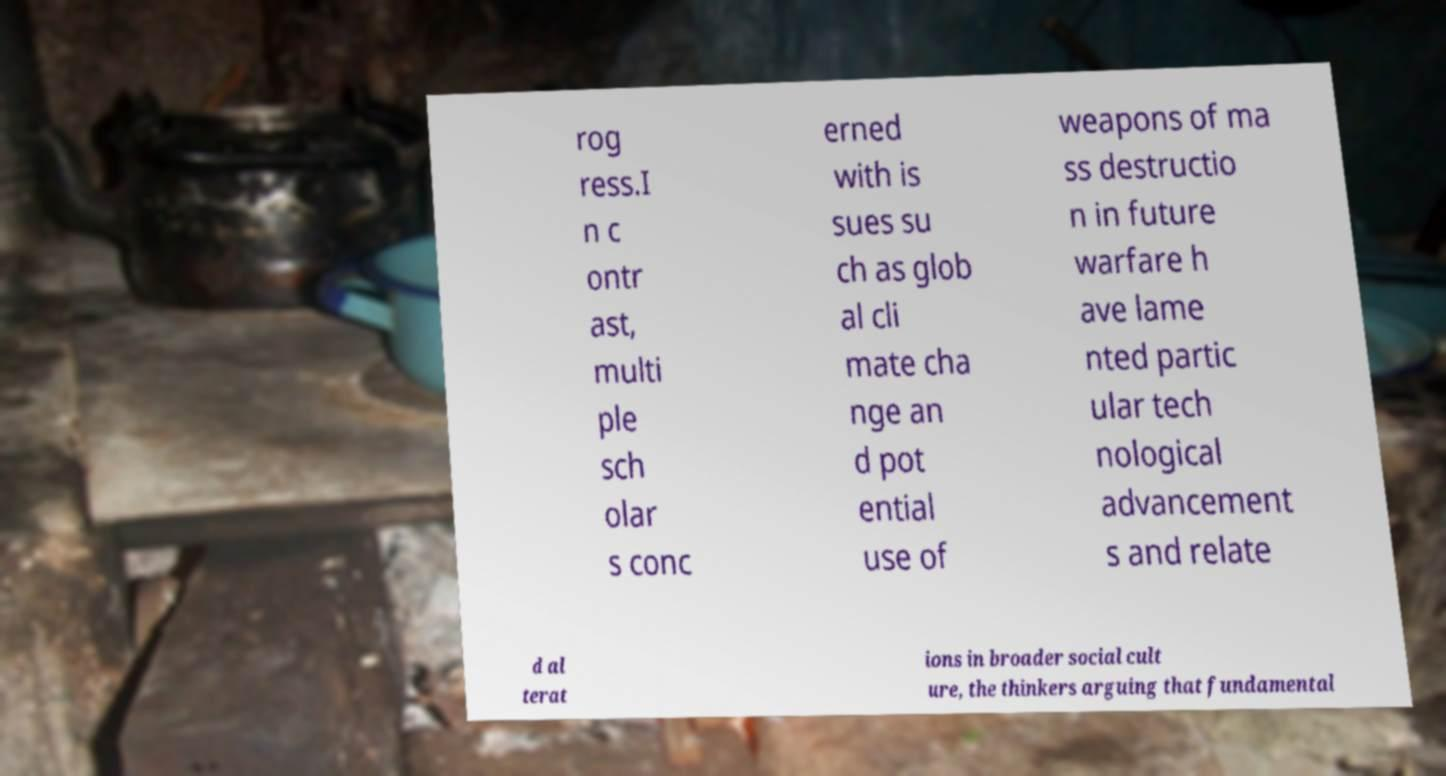What messages or text are displayed in this image? I need them in a readable, typed format. rog ress.I n c ontr ast, multi ple sch olar s conc erned with is sues su ch as glob al cli mate cha nge an d pot ential use of weapons of ma ss destructio n in future warfare h ave lame nted partic ular tech nological advancement s and relate d al terat ions in broader social cult ure, the thinkers arguing that fundamental 